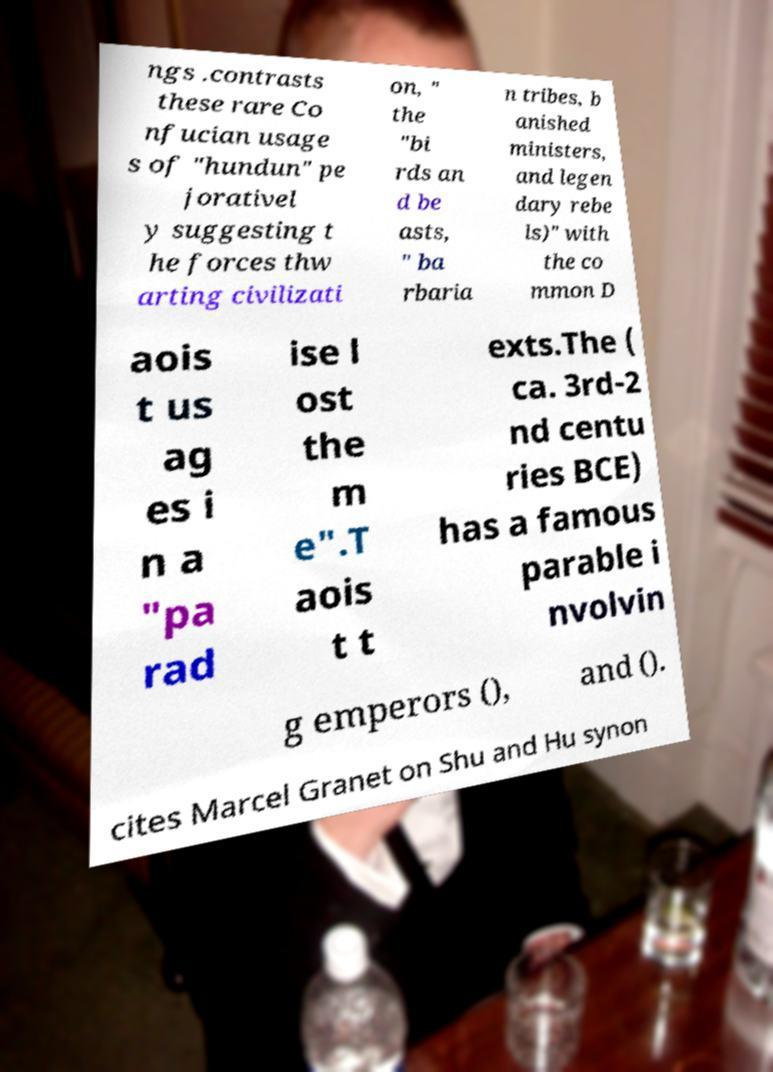Please read and relay the text visible in this image. What does it say? ngs .contrasts these rare Co nfucian usage s of "hundun" pe jorativel y suggesting t he forces thw arting civilizati on, " the "bi rds an d be asts, " ba rbaria n tribes, b anished ministers, and legen dary rebe ls)" with the co mmon D aois t us ag es i n a "pa rad ise l ost the m e".T aois t t exts.The ( ca. 3rd-2 nd centu ries BCE) has a famous parable i nvolvin g emperors (), and (). cites Marcel Granet on Shu and Hu synon 